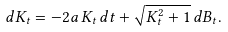<formula> <loc_0><loc_0><loc_500><loc_500>d K _ { t } = - 2 a \, K _ { t } \, d t + \sqrt { K _ { t } ^ { 2 } + 1 } \, d B _ { t } .</formula> 